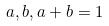Convert formula to latex. <formula><loc_0><loc_0><loc_500><loc_500>a , b , a + b = 1</formula> 